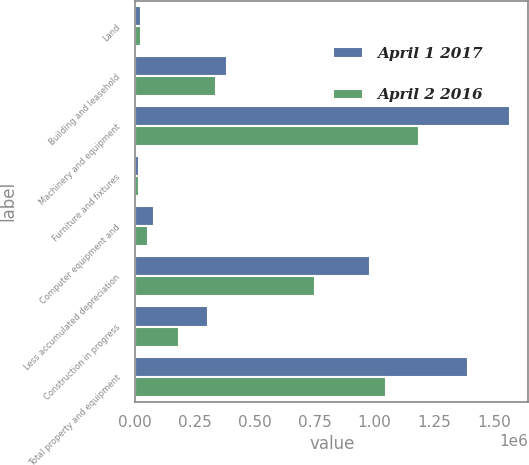Convert chart to OTSL. <chart><loc_0><loc_0><loc_500><loc_500><stacked_bar_chart><ecel><fcel>Land<fcel>Building and leasehold<fcel>Machinery and equipment<fcel>Furniture and fixtures<fcel>Computer equipment and<fcel>Less accumulated depreciation<fcel>Construction in progress<fcel>Total property and equipment<nl><fcel>April 1 2017<fcel>25025<fcel>384784<fcel>1.56523e+06<fcel>14482<fcel>79689<fcel>981328<fcel>304047<fcel>1.39193e+06<nl><fcel>April 2 2016<fcel>25255<fcel>337875<fcel>1.18831e+06<fcel>13884<fcel>51641<fcel>751898<fcel>181821<fcel>1.04689e+06<nl></chart> 